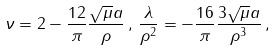Convert formula to latex. <formula><loc_0><loc_0><loc_500><loc_500>\nu = 2 - \frac { 1 2 } { \pi } \frac { \sqrt { \mu } a } { \rho } \, , \, \frac { \lambda } { \rho ^ { 2 } } = - \frac { 1 6 } { \pi } \frac { 3 \sqrt { \mu } a } { \rho ^ { 3 } } \, ,</formula> 